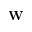<formula> <loc_0><loc_0><loc_500><loc_500>W</formula> 